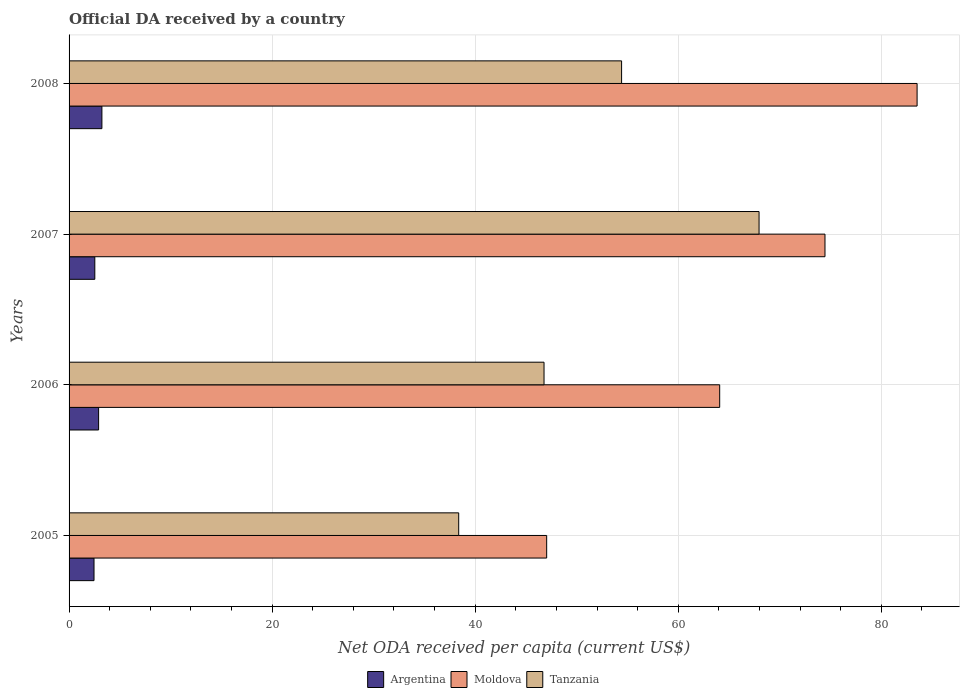How many different coloured bars are there?
Ensure brevity in your answer.  3. How many groups of bars are there?
Make the answer very short. 4. Are the number of bars on each tick of the Y-axis equal?
Provide a short and direct response. Yes. How many bars are there on the 4th tick from the top?
Ensure brevity in your answer.  3. What is the ODA received in in Moldova in 2007?
Offer a very short reply. 74.45. Across all years, what is the maximum ODA received in in Argentina?
Your answer should be very brief. 3.23. Across all years, what is the minimum ODA received in in Argentina?
Make the answer very short. 2.46. What is the total ODA received in in Moldova in the graph?
Give a very brief answer. 269.08. What is the difference between the ODA received in in Tanzania in 2005 and that in 2007?
Give a very brief answer. -29.58. What is the difference between the ODA received in in Tanzania in 2008 and the ODA received in in Argentina in 2007?
Keep it short and to the point. 51.88. What is the average ODA received in in Moldova per year?
Your answer should be compact. 67.27. In the year 2006, what is the difference between the ODA received in in Argentina and ODA received in in Tanzania?
Provide a short and direct response. -43.87. What is the ratio of the ODA received in in Tanzania in 2005 to that in 2008?
Your answer should be compact. 0.71. What is the difference between the highest and the second highest ODA received in in Tanzania?
Your answer should be compact. 13.54. What is the difference between the highest and the lowest ODA received in in Tanzania?
Provide a succinct answer. 29.58. In how many years, is the ODA received in in Argentina greater than the average ODA received in in Argentina taken over all years?
Offer a terse response. 2. What does the 3rd bar from the top in 2007 represents?
Your answer should be compact. Argentina. What does the 2nd bar from the bottom in 2007 represents?
Provide a short and direct response. Moldova. Are all the bars in the graph horizontal?
Provide a succinct answer. Yes. How many years are there in the graph?
Offer a very short reply. 4. Does the graph contain any zero values?
Make the answer very short. No. Where does the legend appear in the graph?
Make the answer very short. Bottom center. What is the title of the graph?
Make the answer very short. Official DA received by a country. What is the label or title of the X-axis?
Your answer should be compact. Net ODA received per capita (current US$). What is the Net ODA received per capita (current US$) of Argentina in 2005?
Provide a short and direct response. 2.46. What is the Net ODA received per capita (current US$) of Moldova in 2005?
Provide a succinct answer. 47.04. What is the Net ODA received per capita (current US$) in Tanzania in 2005?
Offer a terse response. 38.37. What is the Net ODA received per capita (current US$) of Argentina in 2006?
Give a very brief answer. 2.91. What is the Net ODA received per capita (current US$) of Moldova in 2006?
Provide a short and direct response. 64.08. What is the Net ODA received per capita (current US$) of Tanzania in 2006?
Your response must be concise. 46.78. What is the Net ODA received per capita (current US$) in Argentina in 2007?
Your response must be concise. 2.54. What is the Net ODA received per capita (current US$) in Moldova in 2007?
Provide a succinct answer. 74.45. What is the Net ODA received per capita (current US$) of Tanzania in 2007?
Make the answer very short. 67.95. What is the Net ODA received per capita (current US$) of Argentina in 2008?
Give a very brief answer. 3.23. What is the Net ODA received per capita (current US$) of Moldova in 2008?
Keep it short and to the point. 83.52. What is the Net ODA received per capita (current US$) of Tanzania in 2008?
Your response must be concise. 54.42. Across all years, what is the maximum Net ODA received per capita (current US$) in Argentina?
Offer a very short reply. 3.23. Across all years, what is the maximum Net ODA received per capita (current US$) in Moldova?
Ensure brevity in your answer.  83.52. Across all years, what is the maximum Net ODA received per capita (current US$) of Tanzania?
Offer a terse response. 67.95. Across all years, what is the minimum Net ODA received per capita (current US$) in Argentina?
Keep it short and to the point. 2.46. Across all years, what is the minimum Net ODA received per capita (current US$) in Moldova?
Your answer should be compact. 47.04. Across all years, what is the minimum Net ODA received per capita (current US$) in Tanzania?
Your response must be concise. 38.37. What is the total Net ODA received per capita (current US$) of Argentina in the graph?
Ensure brevity in your answer.  11.14. What is the total Net ODA received per capita (current US$) in Moldova in the graph?
Provide a succinct answer. 269.08. What is the total Net ODA received per capita (current US$) of Tanzania in the graph?
Offer a terse response. 207.52. What is the difference between the Net ODA received per capita (current US$) in Argentina in 2005 and that in 2006?
Your response must be concise. -0.45. What is the difference between the Net ODA received per capita (current US$) of Moldova in 2005 and that in 2006?
Give a very brief answer. -17.04. What is the difference between the Net ODA received per capita (current US$) in Tanzania in 2005 and that in 2006?
Ensure brevity in your answer.  -8.4. What is the difference between the Net ODA received per capita (current US$) of Argentina in 2005 and that in 2007?
Your answer should be very brief. -0.08. What is the difference between the Net ODA received per capita (current US$) in Moldova in 2005 and that in 2007?
Make the answer very short. -27.41. What is the difference between the Net ODA received per capita (current US$) of Tanzania in 2005 and that in 2007?
Offer a very short reply. -29.58. What is the difference between the Net ODA received per capita (current US$) in Argentina in 2005 and that in 2008?
Keep it short and to the point. -0.78. What is the difference between the Net ODA received per capita (current US$) in Moldova in 2005 and that in 2008?
Give a very brief answer. -36.48. What is the difference between the Net ODA received per capita (current US$) in Tanzania in 2005 and that in 2008?
Give a very brief answer. -16.04. What is the difference between the Net ODA received per capita (current US$) in Argentina in 2006 and that in 2007?
Your response must be concise. 0.37. What is the difference between the Net ODA received per capita (current US$) in Moldova in 2006 and that in 2007?
Offer a very short reply. -10.37. What is the difference between the Net ODA received per capita (current US$) of Tanzania in 2006 and that in 2007?
Give a very brief answer. -21.18. What is the difference between the Net ODA received per capita (current US$) in Argentina in 2006 and that in 2008?
Your response must be concise. -0.32. What is the difference between the Net ODA received per capita (current US$) of Moldova in 2006 and that in 2008?
Offer a very short reply. -19.44. What is the difference between the Net ODA received per capita (current US$) in Tanzania in 2006 and that in 2008?
Provide a short and direct response. -7.64. What is the difference between the Net ODA received per capita (current US$) of Argentina in 2007 and that in 2008?
Make the answer very short. -0.7. What is the difference between the Net ODA received per capita (current US$) in Moldova in 2007 and that in 2008?
Offer a terse response. -9.07. What is the difference between the Net ODA received per capita (current US$) of Tanzania in 2007 and that in 2008?
Your answer should be compact. 13.54. What is the difference between the Net ODA received per capita (current US$) of Argentina in 2005 and the Net ODA received per capita (current US$) of Moldova in 2006?
Offer a terse response. -61.62. What is the difference between the Net ODA received per capita (current US$) in Argentina in 2005 and the Net ODA received per capita (current US$) in Tanzania in 2006?
Offer a terse response. -44.32. What is the difference between the Net ODA received per capita (current US$) in Moldova in 2005 and the Net ODA received per capita (current US$) in Tanzania in 2006?
Offer a very short reply. 0.26. What is the difference between the Net ODA received per capita (current US$) of Argentina in 2005 and the Net ODA received per capita (current US$) of Moldova in 2007?
Your answer should be very brief. -71.99. What is the difference between the Net ODA received per capita (current US$) of Argentina in 2005 and the Net ODA received per capita (current US$) of Tanzania in 2007?
Provide a succinct answer. -65.5. What is the difference between the Net ODA received per capita (current US$) in Moldova in 2005 and the Net ODA received per capita (current US$) in Tanzania in 2007?
Give a very brief answer. -20.92. What is the difference between the Net ODA received per capita (current US$) of Argentina in 2005 and the Net ODA received per capita (current US$) of Moldova in 2008?
Keep it short and to the point. -81.06. What is the difference between the Net ODA received per capita (current US$) in Argentina in 2005 and the Net ODA received per capita (current US$) in Tanzania in 2008?
Your answer should be compact. -51.96. What is the difference between the Net ODA received per capita (current US$) of Moldova in 2005 and the Net ODA received per capita (current US$) of Tanzania in 2008?
Your response must be concise. -7.38. What is the difference between the Net ODA received per capita (current US$) of Argentina in 2006 and the Net ODA received per capita (current US$) of Moldova in 2007?
Your response must be concise. -71.54. What is the difference between the Net ODA received per capita (current US$) in Argentina in 2006 and the Net ODA received per capita (current US$) in Tanzania in 2007?
Give a very brief answer. -65.05. What is the difference between the Net ODA received per capita (current US$) of Moldova in 2006 and the Net ODA received per capita (current US$) of Tanzania in 2007?
Keep it short and to the point. -3.88. What is the difference between the Net ODA received per capita (current US$) of Argentina in 2006 and the Net ODA received per capita (current US$) of Moldova in 2008?
Ensure brevity in your answer.  -80.61. What is the difference between the Net ODA received per capita (current US$) of Argentina in 2006 and the Net ODA received per capita (current US$) of Tanzania in 2008?
Your answer should be compact. -51.51. What is the difference between the Net ODA received per capita (current US$) in Moldova in 2006 and the Net ODA received per capita (current US$) in Tanzania in 2008?
Your answer should be compact. 9.66. What is the difference between the Net ODA received per capita (current US$) in Argentina in 2007 and the Net ODA received per capita (current US$) in Moldova in 2008?
Keep it short and to the point. -80.98. What is the difference between the Net ODA received per capita (current US$) of Argentina in 2007 and the Net ODA received per capita (current US$) of Tanzania in 2008?
Your answer should be very brief. -51.88. What is the difference between the Net ODA received per capita (current US$) of Moldova in 2007 and the Net ODA received per capita (current US$) of Tanzania in 2008?
Provide a succinct answer. 20.03. What is the average Net ODA received per capita (current US$) in Argentina per year?
Provide a short and direct response. 2.78. What is the average Net ODA received per capita (current US$) of Moldova per year?
Your answer should be compact. 67.27. What is the average Net ODA received per capita (current US$) in Tanzania per year?
Your response must be concise. 51.88. In the year 2005, what is the difference between the Net ODA received per capita (current US$) of Argentina and Net ODA received per capita (current US$) of Moldova?
Your response must be concise. -44.58. In the year 2005, what is the difference between the Net ODA received per capita (current US$) in Argentina and Net ODA received per capita (current US$) in Tanzania?
Your response must be concise. -35.92. In the year 2005, what is the difference between the Net ODA received per capita (current US$) of Moldova and Net ODA received per capita (current US$) of Tanzania?
Your answer should be very brief. 8.66. In the year 2006, what is the difference between the Net ODA received per capita (current US$) in Argentina and Net ODA received per capita (current US$) in Moldova?
Your answer should be very brief. -61.17. In the year 2006, what is the difference between the Net ODA received per capita (current US$) in Argentina and Net ODA received per capita (current US$) in Tanzania?
Give a very brief answer. -43.87. In the year 2006, what is the difference between the Net ODA received per capita (current US$) of Moldova and Net ODA received per capita (current US$) of Tanzania?
Your response must be concise. 17.3. In the year 2007, what is the difference between the Net ODA received per capita (current US$) in Argentina and Net ODA received per capita (current US$) in Moldova?
Offer a very short reply. -71.91. In the year 2007, what is the difference between the Net ODA received per capita (current US$) in Argentina and Net ODA received per capita (current US$) in Tanzania?
Your answer should be very brief. -65.42. In the year 2007, what is the difference between the Net ODA received per capita (current US$) in Moldova and Net ODA received per capita (current US$) in Tanzania?
Your response must be concise. 6.49. In the year 2008, what is the difference between the Net ODA received per capita (current US$) in Argentina and Net ODA received per capita (current US$) in Moldova?
Keep it short and to the point. -80.28. In the year 2008, what is the difference between the Net ODA received per capita (current US$) of Argentina and Net ODA received per capita (current US$) of Tanzania?
Give a very brief answer. -51.18. In the year 2008, what is the difference between the Net ODA received per capita (current US$) of Moldova and Net ODA received per capita (current US$) of Tanzania?
Your response must be concise. 29.1. What is the ratio of the Net ODA received per capita (current US$) of Argentina in 2005 to that in 2006?
Your answer should be compact. 0.84. What is the ratio of the Net ODA received per capita (current US$) in Moldova in 2005 to that in 2006?
Offer a terse response. 0.73. What is the ratio of the Net ODA received per capita (current US$) of Tanzania in 2005 to that in 2006?
Your answer should be compact. 0.82. What is the ratio of the Net ODA received per capita (current US$) in Argentina in 2005 to that in 2007?
Keep it short and to the point. 0.97. What is the ratio of the Net ODA received per capita (current US$) in Moldova in 2005 to that in 2007?
Keep it short and to the point. 0.63. What is the ratio of the Net ODA received per capita (current US$) in Tanzania in 2005 to that in 2007?
Make the answer very short. 0.56. What is the ratio of the Net ODA received per capita (current US$) in Argentina in 2005 to that in 2008?
Make the answer very short. 0.76. What is the ratio of the Net ODA received per capita (current US$) in Moldova in 2005 to that in 2008?
Your answer should be very brief. 0.56. What is the ratio of the Net ODA received per capita (current US$) in Tanzania in 2005 to that in 2008?
Your answer should be compact. 0.71. What is the ratio of the Net ODA received per capita (current US$) of Argentina in 2006 to that in 2007?
Ensure brevity in your answer.  1.15. What is the ratio of the Net ODA received per capita (current US$) of Moldova in 2006 to that in 2007?
Offer a very short reply. 0.86. What is the ratio of the Net ODA received per capita (current US$) in Tanzania in 2006 to that in 2007?
Give a very brief answer. 0.69. What is the ratio of the Net ODA received per capita (current US$) of Argentina in 2006 to that in 2008?
Offer a very short reply. 0.9. What is the ratio of the Net ODA received per capita (current US$) of Moldova in 2006 to that in 2008?
Provide a succinct answer. 0.77. What is the ratio of the Net ODA received per capita (current US$) in Tanzania in 2006 to that in 2008?
Provide a short and direct response. 0.86. What is the ratio of the Net ODA received per capita (current US$) of Argentina in 2007 to that in 2008?
Offer a very short reply. 0.78. What is the ratio of the Net ODA received per capita (current US$) in Moldova in 2007 to that in 2008?
Your answer should be very brief. 0.89. What is the ratio of the Net ODA received per capita (current US$) of Tanzania in 2007 to that in 2008?
Ensure brevity in your answer.  1.25. What is the difference between the highest and the second highest Net ODA received per capita (current US$) in Argentina?
Keep it short and to the point. 0.32. What is the difference between the highest and the second highest Net ODA received per capita (current US$) of Moldova?
Your answer should be very brief. 9.07. What is the difference between the highest and the second highest Net ODA received per capita (current US$) of Tanzania?
Offer a very short reply. 13.54. What is the difference between the highest and the lowest Net ODA received per capita (current US$) of Argentina?
Provide a succinct answer. 0.78. What is the difference between the highest and the lowest Net ODA received per capita (current US$) of Moldova?
Keep it short and to the point. 36.48. What is the difference between the highest and the lowest Net ODA received per capita (current US$) of Tanzania?
Offer a terse response. 29.58. 